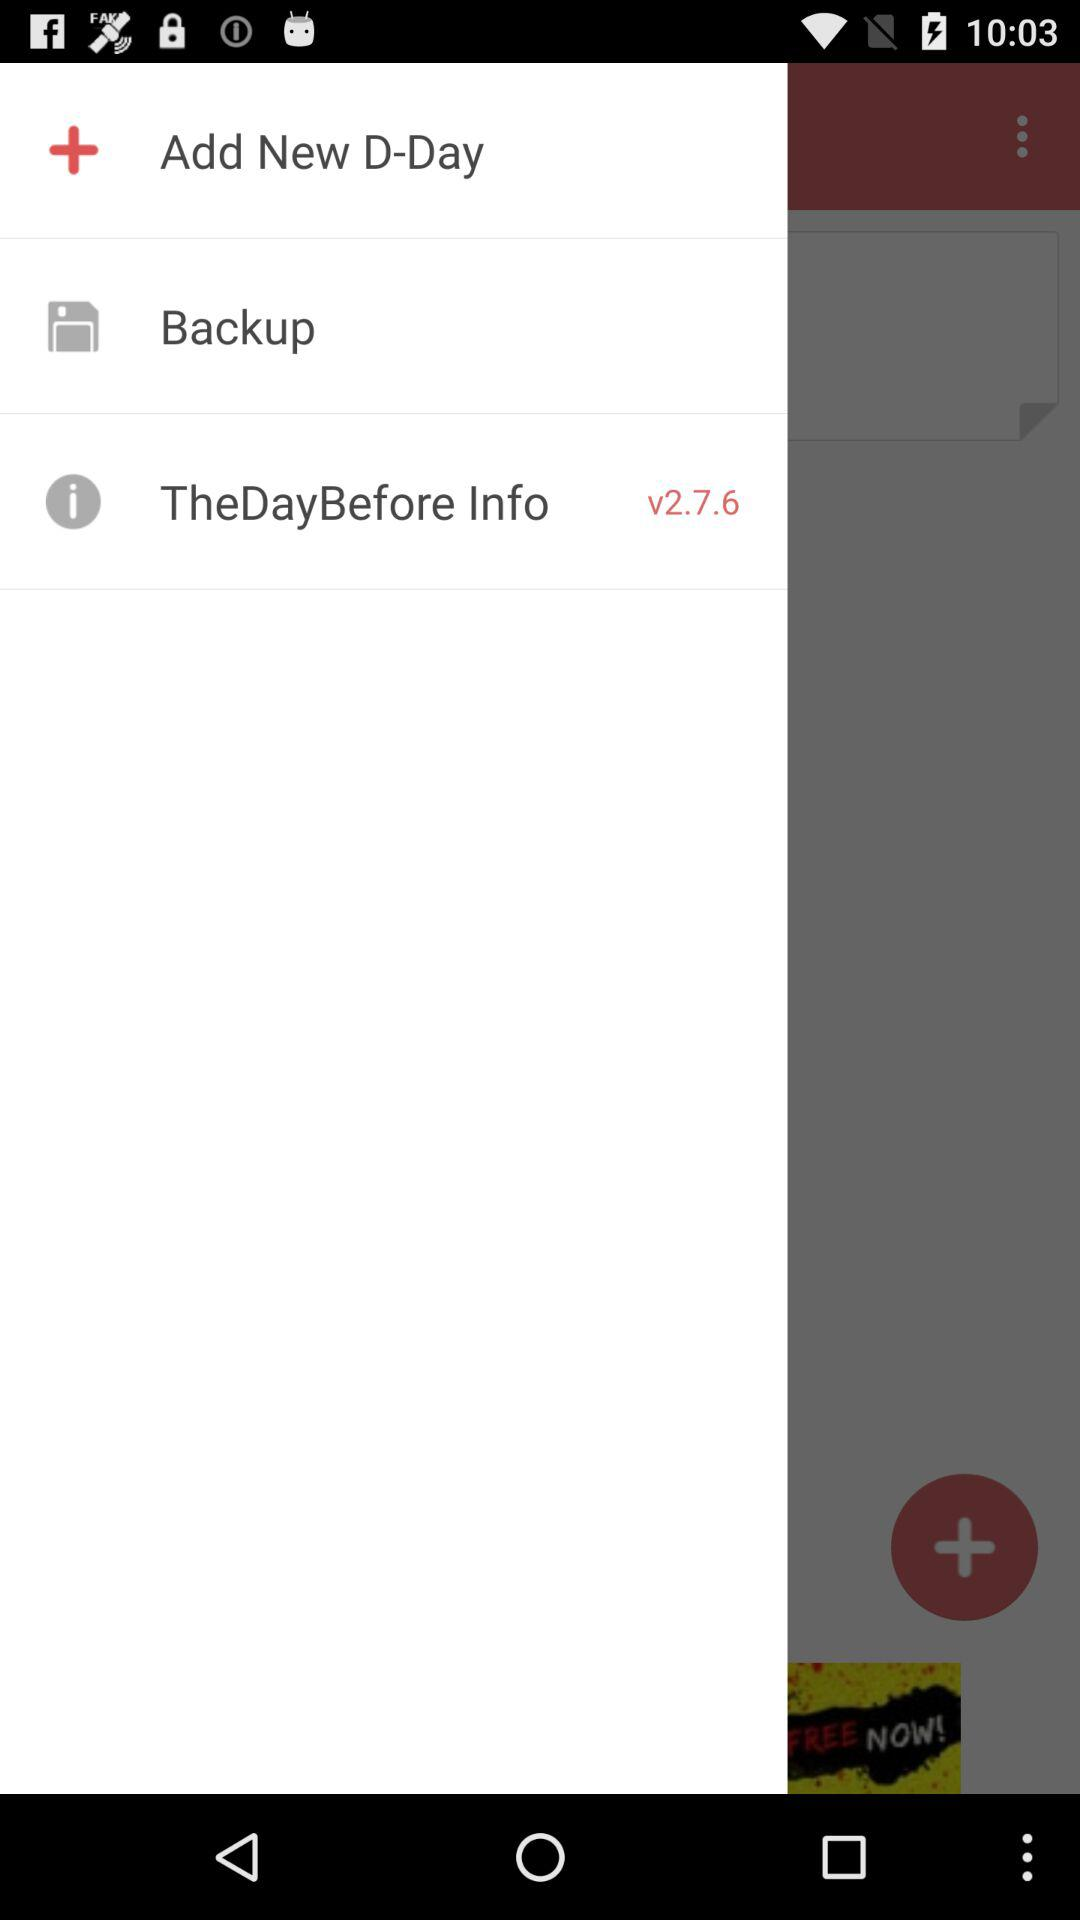What version is used? The version is v2.7.6. 